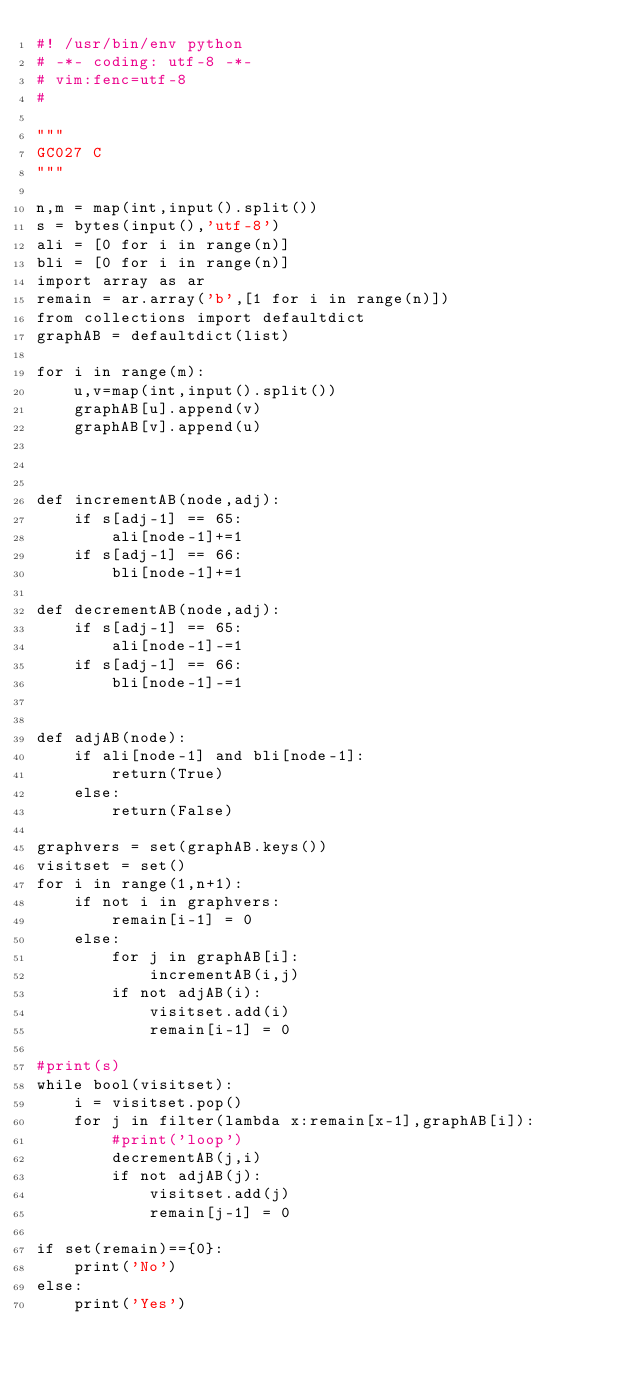Convert code to text. <code><loc_0><loc_0><loc_500><loc_500><_Python_>#! /usr/bin/env python
# -*- coding: utf-8 -*-
# vim:fenc=utf-8
#

"""
GC027 C
"""

n,m = map(int,input().split())
s = bytes(input(),'utf-8')
ali = [0 for i in range(n)]
bli = [0 for i in range(n)]
import array as ar
remain = ar.array('b',[1 for i in range(n)])
from collections import defaultdict
graphAB = defaultdict(list)

for i in range(m):
    u,v=map(int,input().split())
    graphAB[u].append(v)
    graphAB[v].append(u)



def incrementAB(node,adj):
    if s[adj-1] == 65:
        ali[node-1]+=1
    if s[adj-1] == 66:
        bli[node-1]+=1

def decrementAB(node,adj):
    if s[adj-1] == 65:
        ali[node-1]-=1
    if s[adj-1] == 66:
        bli[node-1]-=1


def adjAB(node):
    if ali[node-1] and bli[node-1]:
        return(True)
    else:
        return(False)

graphvers = set(graphAB.keys())
visitset = set()
for i in range(1,n+1):
    if not i in graphvers:
        remain[i-1] = 0
    else:
        for j in graphAB[i]:
            incrementAB(i,j)
        if not adjAB(i):
            visitset.add(i)
            remain[i-1] = 0

#print(s)
while bool(visitset):
    i = visitset.pop()
    for j in filter(lambda x:remain[x-1],graphAB[i]):
        #print('loop')
        decrementAB(j,i)
        if not adjAB(j):
            visitset.add(j)
            remain[j-1] = 0

if set(remain)=={0}:
    print('No')
else:
    print('Yes')



</code> 